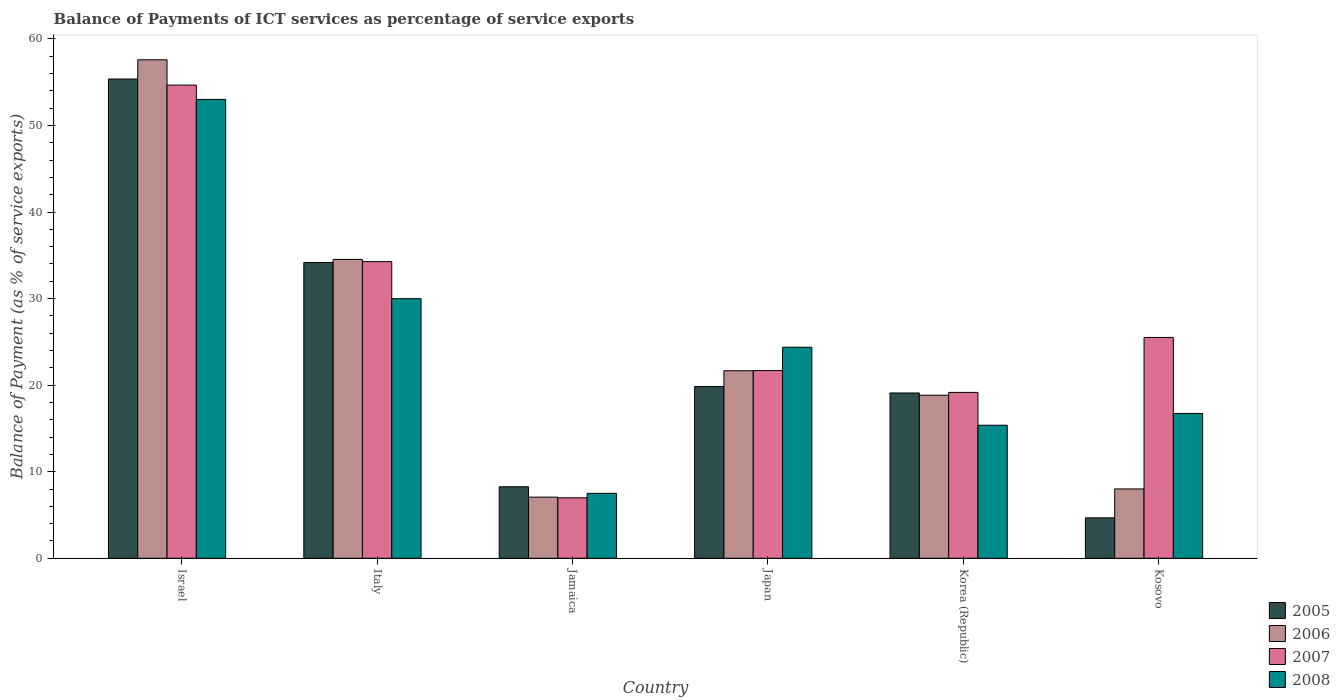How many different coloured bars are there?
Offer a terse response. 4. How many groups of bars are there?
Keep it short and to the point. 6. Are the number of bars on each tick of the X-axis equal?
Offer a very short reply. Yes. How many bars are there on the 2nd tick from the right?
Offer a very short reply. 4. What is the label of the 5th group of bars from the left?
Your answer should be very brief. Korea (Republic). What is the balance of payments of ICT services in 2005 in Italy?
Your answer should be very brief. 34.17. Across all countries, what is the maximum balance of payments of ICT services in 2006?
Ensure brevity in your answer.  57.59. Across all countries, what is the minimum balance of payments of ICT services in 2008?
Make the answer very short. 7.5. In which country was the balance of payments of ICT services in 2005 maximum?
Make the answer very short. Israel. In which country was the balance of payments of ICT services in 2007 minimum?
Give a very brief answer. Jamaica. What is the total balance of payments of ICT services in 2008 in the graph?
Your response must be concise. 147. What is the difference between the balance of payments of ICT services in 2005 in Japan and that in Korea (Republic)?
Your answer should be very brief. 0.75. What is the difference between the balance of payments of ICT services in 2007 in Italy and the balance of payments of ICT services in 2008 in Kosovo?
Ensure brevity in your answer.  17.54. What is the average balance of payments of ICT services in 2005 per country?
Your answer should be compact. 23.57. What is the difference between the balance of payments of ICT services of/in 2005 and balance of payments of ICT services of/in 2007 in Japan?
Your response must be concise. -1.84. In how many countries, is the balance of payments of ICT services in 2005 greater than 22 %?
Offer a very short reply. 2. What is the ratio of the balance of payments of ICT services in 2007 in Israel to that in Japan?
Offer a terse response. 2.52. What is the difference between the highest and the second highest balance of payments of ICT services in 2008?
Provide a short and direct response. -5.61. What is the difference between the highest and the lowest balance of payments of ICT services in 2005?
Provide a short and direct response. 50.7. In how many countries, is the balance of payments of ICT services in 2005 greater than the average balance of payments of ICT services in 2005 taken over all countries?
Your response must be concise. 2. Is it the case that in every country, the sum of the balance of payments of ICT services in 2007 and balance of payments of ICT services in 2008 is greater than the balance of payments of ICT services in 2005?
Offer a very short reply. Yes. Are all the bars in the graph horizontal?
Give a very brief answer. No. What is the difference between two consecutive major ticks on the Y-axis?
Your response must be concise. 10. Does the graph contain grids?
Provide a short and direct response. No. Where does the legend appear in the graph?
Provide a short and direct response. Bottom right. How are the legend labels stacked?
Make the answer very short. Vertical. What is the title of the graph?
Offer a terse response. Balance of Payments of ICT services as percentage of service exports. What is the label or title of the X-axis?
Offer a very short reply. Country. What is the label or title of the Y-axis?
Offer a very short reply. Balance of Payment (as % of service exports). What is the Balance of Payment (as % of service exports) of 2005 in Israel?
Ensure brevity in your answer.  55.37. What is the Balance of Payment (as % of service exports) of 2006 in Israel?
Ensure brevity in your answer.  57.59. What is the Balance of Payment (as % of service exports) in 2007 in Israel?
Provide a succinct answer. 54.67. What is the Balance of Payment (as % of service exports) in 2008 in Israel?
Provide a succinct answer. 53.02. What is the Balance of Payment (as % of service exports) of 2005 in Italy?
Make the answer very short. 34.17. What is the Balance of Payment (as % of service exports) of 2006 in Italy?
Your answer should be very brief. 34.53. What is the Balance of Payment (as % of service exports) in 2007 in Italy?
Make the answer very short. 34.28. What is the Balance of Payment (as % of service exports) of 2008 in Italy?
Your response must be concise. 29.99. What is the Balance of Payment (as % of service exports) in 2005 in Jamaica?
Offer a very short reply. 8.26. What is the Balance of Payment (as % of service exports) of 2006 in Jamaica?
Your answer should be very brief. 7.06. What is the Balance of Payment (as % of service exports) of 2007 in Jamaica?
Give a very brief answer. 6.99. What is the Balance of Payment (as % of service exports) in 2008 in Jamaica?
Give a very brief answer. 7.5. What is the Balance of Payment (as % of service exports) of 2005 in Japan?
Offer a very short reply. 19.85. What is the Balance of Payment (as % of service exports) in 2006 in Japan?
Offer a terse response. 21.67. What is the Balance of Payment (as % of service exports) of 2007 in Japan?
Give a very brief answer. 21.69. What is the Balance of Payment (as % of service exports) of 2008 in Japan?
Your response must be concise. 24.38. What is the Balance of Payment (as % of service exports) in 2005 in Korea (Republic)?
Offer a terse response. 19.1. What is the Balance of Payment (as % of service exports) in 2006 in Korea (Republic)?
Your answer should be compact. 18.84. What is the Balance of Payment (as % of service exports) in 2007 in Korea (Republic)?
Your answer should be compact. 19.16. What is the Balance of Payment (as % of service exports) in 2008 in Korea (Republic)?
Give a very brief answer. 15.37. What is the Balance of Payment (as % of service exports) of 2005 in Kosovo?
Offer a very short reply. 4.67. What is the Balance of Payment (as % of service exports) of 2006 in Kosovo?
Provide a succinct answer. 8.01. What is the Balance of Payment (as % of service exports) in 2007 in Kosovo?
Provide a short and direct response. 25.51. What is the Balance of Payment (as % of service exports) of 2008 in Kosovo?
Your answer should be compact. 16.73. Across all countries, what is the maximum Balance of Payment (as % of service exports) of 2005?
Your answer should be very brief. 55.37. Across all countries, what is the maximum Balance of Payment (as % of service exports) of 2006?
Offer a terse response. 57.59. Across all countries, what is the maximum Balance of Payment (as % of service exports) in 2007?
Give a very brief answer. 54.67. Across all countries, what is the maximum Balance of Payment (as % of service exports) of 2008?
Ensure brevity in your answer.  53.02. Across all countries, what is the minimum Balance of Payment (as % of service exports) of 2005?
Make the answer very short. 4.67. Across all countries, what is the minimum Balance of Payment (as % of service exports) of 2006?
Your answer should be very brief. 7.06. Across all countries, what is the minimum Balance of Payment (as % of service exports) in 2007?
Ensure brevity in your answer.  6.99. Across all countries, what is the minimum Balance of Payment (as % of service exports) in 2008?
Offer a very short reply. 7.5. What is the total Balance of Payment (as % of service exports) in 2005 in the graph?
Your response must be concise. 141.43. What is the total Balance of Payment (as % of service exports) in 2006 in the graph?
Your response must be concise. 147.7. What is the total Balance of Payment (as % of service exports) of 2007 in the graph?
Your response must be concise. 162.29. What is the total Balance of Payment (as % of service exports) in 2008 in the graph?
Keep it short and to the point. 147. What is the difference between the Balance of Payment (as % of service exports) in 2005 in Israel and that in Italy?
Ensure brevity in your answer.  21.2. What is the difference between the Balance of Payment (as % of service exports) of 2006 in Israel and that in Italy?
Provide a short and direct response. 23.06. What is the difference between the Balance of Payment (as % of service exports) of 2007 in Israel and that in Italy?
Offer a terse response. 20.39. What is the difference between the Balance of Payment (as % of service exports) in 2008 in Israel and that in Italy?
Ensure brevity in your answer.  23.02. What is the difference between the Balance of Payment (as % of service exports) in 2005 in Israel and that in Jamaica?
Provide a short and direct response. 47.11. What is the difference between the Balance of Payment (as % of service exports) in 2006 in Israel and that in Jamaica?
Make the answer very short. 50.53. What is the difference between the Balance of Payment (as % of service exports) in 2007 in Israel and that in Jamaica?
Offer a very short reply. 47.68. What is the difference between the Balance of Payment (as % of service exports) in 2008 in Israel and that in Jamaica?
Give a very brief answer. 45.51. What is the difference between the Balance of Payment (as % of service exports) in 2005 in Israel and that in Japan?
Give a very brief answer. 35.52. What is the difference between the Balance of Payment (as % of service exports) of 2006 in Israel and that in Japan?
Your response must be concise. 35.93. What is the difference between the Balance of Payment (as % of service exports) in 2007 in Israel and that in Japan?
Make the answer very short. 32.98. What is the difference between the Balance of Payment (as % of service exports) of 2008 in Israel and that in Japan?
Provide a short and direct response. 28.64. What is the difference between the Balance of Payment (as % of service exports) of 2005 in Israel and that in Korea (Republic)?
Ensure brevity in your answer.  36.28. What is the difference between the Balance of Payment (as % of service exports) of 2006 in Israel and that in Korea (Republic)?
Your response must be concise. 38.75. What is the difference between the Balance of Payment (as % of service exports) of 2007 in Israel and that in Korea (Republic)?
Your response must be concise. 35.5. What is the difference between the Balance of Payment (as % of service exports) in 2008 in Israel and that in Korea (Republic)?
Keep it short and to the point. 37.64. What is the difference between the Balance of Payment (as % of service exports) in 2005 in Israel and that in Kosovo?
Keep it short and to the point. 50.7. What is the difference between the Balance of Payment (as % of service exports) of 2006 in Israel and that in Kosovo?
Your answer should be very brief. 49.58. What is the difference between the Balance of Payment (as % of service exports) of 2007 in Israel and that in Kosovo?
Your answer should be very brief. 29.15. What is the difference between the Balance of Payment (as % of service exports) in 2008 in Israel and that in Kosovo?
Your answer should be very brief. 36.29. What is the difference between the Balance of Payment (as % of service exports) of 2005 in Italy and that in Jamaica?
Offer a terse response. 25.91. What is the difference between the Balance of Payment (as % of service exports) of 2006 in Italy and that in Jamaica?
Offer a terse response. 27.47. What is the difference between the Balance of Payment (as % of service exports) in 2007 in Italy and that in Jamaica?
Offer a very short reply. 27.29. What is the difference between the Balance of Payment (as % of service exports) of 2008 in Italy and that in Jamaica?
Provide a succinct answer. 22.49. What is the difference between the Balance of Payment (as % of service exports) in 2005 in Italy and that in Japan?
Give a very brief answer. 14.33. What is the difference between the Balance of Payment (as % of service exports) in 2006 in Italy and that in Japan?
Your answer should be very brief. 12.87. What is the difference between the Balance of Payment (as % of service exports) of 2007 in Italy and that in Japan?
Your answer should be very brief. 12.59. What is the difference between the Balance of Payment (as % of service exports) in 2008 in Italy and that in Japan?
Make the answer very short. 5.61. What is the difference between the Balance of Payment (as % of service exports) of 2005 in Italy and that in Korea (Republic)?
Your answer should be compact. 15.08. What is the difference between the Balance of Payment (as % of service exports) in 2006 in Italy and that in Korea (Republic)?
Give a very brief answer. 15.69. What is the difference between the Balance of Payment (as % of service exports) of 2007 in Italy and that in Korea (Republic)?
Give a very brief answer. 15.11. What is the difference between the Balance of Payment (as % of service exports) in 2008 in Italy and that in Korea (Republic)?
Provide a succinct answer. 14.62. What is the difference between the Balance of Payment (as % of service exports) of 2005 in Italy and that in Kosovo?
Make the answer very short. 29.5. What is the difference between the Balance of Payment (as % of service exports) in 2006 in Italy and that in Kosovo?
Keep it short and to the point. 26.52. What is the difference between the Balance of Payment (as % of service exports) in 2007 in Italy and that in Kosovo?
Your response must be concise. 8.76. What is the difference between the Balance of Payment (as % of service exports) in 2008 in Italy and that in Kosovo?
Provide a short and direct response. 13.26. What is the difference between the Balance of Payment (as % of service exports) of 2005 in Jamaica and that in Japan?
Offer a very short reply. -11.59. What is the difference between the Balance of Payment (as % of service exports) in 2006 in Jamaica and that in Japan?
Give a very brief answer. -14.6. What is the difference between the Balance of Payment (as % of service exports) of 2007 in Jamaica and that in Japan?
Keep it short and to the point. -14.7. What is the difference between the Balance of Payment (as % of service exports) in 2008 in Jamaica and that in Japan?
Offer a terse response. -16.88. What is the difference between the Balance of Payment (as % of service exports) in 2005 in Jamaica and that in Korea (Republic)?
Give a very brief answer. -10.83. What is the difference between the Balance of Payment (as % of service exports) of 2006 in Jamaica and that in Korea (Republic)?
Provide a succinct answer. -11.78. What is the difference between the Balance of Payment (as % of service exports) of 2007 in Jamaica and that in Korea (Republic)?
Provide a short and direct response. -12.18. What is the difference between the Balance of Payment (as % of service exports) of 2008 in Jamaica and that in Korea (Republic)?
Offer a terse response. -7.87. What is the difference between the Balance of Payment (as % of service exports) of 2005 in Jamaica and that in Kosovo?
Give a very brief answer. 3.59. What is the difference between the Balance of Payment (as % of service exports) in 2006 in Jamaica and that in Kosovo?
Give a very brief answer. -0.95. What is the difference between the Balance of Payment (as % of service exports) of 2007 in Jamaica and that in Kosovo?
Your answer should be compact. -18.53. What is the difference between the Balance of Payment (as % of service exports) in 2008 in Jamaica and that in Kosovo?
Make the answer very short. -9.23. What is the difference between the Balance of Payment (as % of service exports) of 2005 in Japan and that in Korea (Republic)?
Your answer should be very brief. 0.75. What is the difference between the Balance of Payment (as % of service exports) of 2006 in Japan and that in Korea (Republic)?
Your answer should be compact. 2.83. What is the difference between the Balance of Payment (as % of service exports) of 2007 in Japan and that in Korea (Republic)?
Your response must be concise. 2.52. What is the difference between the Balance of Payment (as % of service exports) in 2008 in Japan and that in Korea (Republic)?
Offer a very short reply. 9.01. What is the difference between the Balance of Payment (as % of service exports) of 2005 in Japan and that in Kosovo?
Your response must be concise. 15.18. What is the difference between the Balance of Payment (as % of service exports) in 2006 in Japan and that in Kosovo?
Your answer should be very brief. 13.66. What is the difference between the Balance of Payment (as % of service exports) of 2007 in Japan and that in Kosovo?
Your answer should be very brief. -3.83. What is the difference between the Balance of Payment (as % of service exports) in 2008 in Japan and that in Kosovo?
Give a very brief answer. 7.65. What is the difference between the Balance of Payment (as % of service exports) of 2005 in Korea (Republic) and that in Kosovo?
Give a very brief answer. 14.43. What is the difference between the Balance of Payment (as % of service exports) in 2006 in Korea (Republic) and that in Kosovo?
Your response must be concise. 10.83. What is the difference between the Balance of Payment (as % of service exports) of 2007 in Korea (Republic) and that in Kosovo?
Provide a succinct answer. -6.35. What is the difference between the Balance of Payment (as % of service exports) of 2008 in Korea (Republic) and that in Kosovo?
Provide a short and direct response. -1.36. What is the difference between the Balance of Payment (as % of service exports) in 2005 in Israel and the Balance of Payment (as % of service exports) in 2006 in Italy?
Offer a terse response. 20.84. What is the difference between the Balance of Payment (as % of service exports) of 2005 in Israel and the Balance of Payment (as % of service exports) of 2007 in Italy?
Ensure brevity in your answer.  21.1. What is the difference between the Balance of Payment (as % of service exports) in 2005 in Israel and the Balance of Payment (as % of service exports) in 2008 in Italy?
Offer a very short reply. 25.38. What is the difference between the Balance of Payment (as % of service exports) in 2006 in Israel and the Balance of Payment (as % of service exports) in 2007 in Italy?
Give a very brief answer. 23.32. What is the difference between the Balance of Payment (as % of service exports) in 2006 in Israel and the Balance of Payment (as % of service exports) in 2008 in Italy?
Ensure brevity in your answer.  27.6. What is the difference between the Balance of Payment (as % of service exports) in 2007 in Israel and the Balance of Payment (as % of service exports) in 2008 in Italy?
Make the answer very short. 24.67. What is the difference between the Balance of Payment (as % of service exports) in 2005 in Israel and the Balance of Payment (as % of service exports) in 2006 in Jamaica?
Make the answer very short. 48.31. What is the difference between the Balance of Payment (as % of service exports) of 2005 in Israel and the Balance of Payment (as % of service exports) of 2007 in Jamaica?
Offer a very short reply. 48.39. What is the difference between the Balance of Payment (as % of service exports) of 2005 in Israel and the Balance of Payment (as % of service exports) of 2008 in Jamaica?
Keep it short and to the point. 47.87. What is the difference between the Balance of Payment (as % of service exports) in 2006 in Israel and the Balance of Payment (as % of service exports) in 2007 in Jamaica?
Provide a succinct answer. 50.61. What is the difference between the Balance of Payment (as % of service exports) in 2006 in Israel and the Balance of Payment (as % of service exports) in 2008 in Jamaica?
Provide a succinct answer. 50.09. What is the difference between the Balance of Payment (as % of service exports) in 2007 in Israel and the Balance of Payment (as % of service exports) in 2008 in Jamaica?
Your answer should be very brief. 47.16. What is the difference between the Balance of Payment (as % of service exports) of 2005 in Israel and the Balance of Payment (as % of service exports) of 2006 in Japan?
Your answer should be compact. 33.71. What is the difference between the Balance of Payment (as % of service exports) of 2005 in Israel and the Balance of Payment (as % of service exports) of 2007 in Japan?
Make the answer very short. 33.69. What is the difference between the Balance of Payment (as % of service exports) in 2005 in Israel and the Balance of Payment (as % of service exports) in 2008 in Japan?
Your answer should be very brief. 30.99. What is the difference between the Balance of Payment (as % of service exports) of 2006 in Israel and the Balance of Payment (as % of service exports) of 2007 in Japan?
Offer a very short reply. 35.91. What is the difference between the Balance of Payment (as % of service exports) in 2006 in Israel and the Balance of Payment (as % of service exports) in 2008 in Japan?
Offer a terse response. 33.21. What is the difference between the Balance of Payment (as % of service exports) in 2007 in Israel and the Balance of Payment (as % of service exports) in 2008 in Japan?
Your answer should be very brief. 30.28. What is the difference between the Balance of Payment (as % of service exports) of 2005 in Israel and the Balance of Payment (as % of service exports) of 2006 in Korea (Republic)?
Your answer should be compact. 36.53. What is the difference between the Balance of Payment (as % of service exports) of 2005 in Israel and the Balance of Payment (as % of service exports) of 2007 in Korea (Republic)?
Provide a short and direct response. 36.21. What is the difference between the Balance of Payment (as % of service exports) of 2005 in Israel and the Balance of Payment (as % of service exports) of 2008 in Korea (Republic)?
Your answer should be very brief. 40. What is the difference between the Balance of Payment (as % of service exports) in 2006 in Israel and the Balance of Payment (as % of service exports) in 2007 in Korea (Republic)?
Your answer should be compact. 38.43. What is the difference between the Balance of Payment (as % of service exports) in 2006 in Israel and the Balance of Payment (as % of service exports) in 2008 in Korea (Republic)?
Provide a succinct answer. 42.22. What is the difference between the Balance of Payment (as % of service exports) in 2007 in Israel and the Balance of Payment (as % of service exports) in 2008 in Korea (Republic)?
Offer a very short reply. 39.29. What is the difference between the Balance of Payment (as % of service exports) of 2005 in Israel and the Balance of Payment (as % of service exports) of 2006 in Kosovo?
Provide a succinct answer. 47.36. What is the difference between the Balance of Payment (as % of service exports) in 2005 in Israel and the Balance of Payment (as % of service exports) in 2007 in Kosovo?
Provide a succinct answer. 29.86. What is the difference between the Balance of Payment (as % of service exports) in 2005 in Israel and the Balance of Payment (as % of service exports) in 2008 in Kosovo?
Your answer should be very brief. 38.64. What is the difference between the Balance of Payment (as % of service exports) in 2006 in Israel and the Balance of Payment (as % of service exports) in 2007 in Kosovo?
Your answer should be very brief. 32.08. What is the difference between the Balance of Payment (as % of service exports) of 2006 in Israel and the Balance of Payment (as % of service exports) of 2008 in Kosovo?
Your answer should be very brief. 40.86. What is the difference between the Balance of Payment (as % of service exports) of 2007 in Israel and the Balance of Payment (as % of service exports) of 2008 in Kosovo?
Ensure brevity in your answer.  37.94. What is the difference between the Balance of Payment (as % of service exports) of 2005 in Italy and the Balance of Payment (as % of service exports) of 2006 in Jamaica?
Your answer should be compact. 27.11. What is the difference between the Balance of Payment (as % of service exports) in 2005 in Italy and the Balance of Payment (as % of service exports) in 2007 in Jamaica?
Keep it short and to the point. 27.19. What is the difference between the Balance of Payment (as % of service exports) in 2005 in Italy and the Balance of Payment (as % of service exports) in 2008 in Jamaica?
Make the answer very short. 26.67. What is the difference between the Balance of Payment (as % of service exports) in 2006 in Italy and the Balance of Payment (as % of service exports) in 2007 in Jamaica?
Keep it short and to the point. 27.54. What is the difference between the Balance of Payment (as % of service exports) in 2006 in Italy and the Balance of Payment (as % of service exports) in 2008 in Jamaica?
Offer a terse response. 27.03. What is the difference between the Balance of Payment (as % of service exports) of 2007 in Italy and the Balance of Payment (as % of service exports) of 2008 in Jamaica?
Offer a terse response. 26.77. What is the difference between the Balance of Payment (as % of service exports) in 2005 in Italy and the Balance of Payment (as % of service exports) in 2006 in Japan?
Offer a very short reply. 12.51. What is the difference between the Balance of Payment (as % of service exports) of 2005 in Italy and the Balance of Payment (as % of service exports) of 2007 in Japan?
Ensure brevity in your answer.  12.49. What is the difference between the Balance of Payment (as % of service exports) in 2005 in Italy and the Balance of Payment (as % of service exports) in 2008 in Japan?
Ensure brevity in your answer.  9.79. What is the difference between the Balance of Payment (as % of service exports) of 2006 in Italy and the Balance of Payment (as % of service exports) of 2007 in Japan?
Offer a very short reply. 12.85. What is the difference between the Balance of Payment (as % of service exports) in 2006 in Italy and the Balance of Payment (as % of service exports) in 2008 in Japan?
Ensure brevity in your answer.  10.15. What is the difference between the Balance of Payment (as % of service exports) of 2007 in Italy and the Balance of Payment (as % of service exports) of 2008 in Japan?
Keep it short and to the point. 9.89. What is the difference between the Balance of Payment (as % of service exports) in 2005 in Italy and the Balance of Payment (as % of service exports) in 2006 in Korea (Republic)?
Provide a short and direct response. 15.34. What is the difference between the Balance of Payment (as % of service exports) of 2005 in Italy and the Balance of Payment (as % of service exports) of 2007 in Korea (Republic)?
Offer a very short reply. 15.01. What is the difference between the Balance of Payment (as % of service exports) of 2005 in Italy and the Balance of Payment (as % of service exports) of 2008 in Korea (Republic)?
Ensure brevity in your answer.  18.8. What is the difference between the Balance of Payment (as % of service exports) in 2006 in Italy and the Balance of Payment (as % of service exports) in 2007 in Korea (Republic)?
Give a very brief answer. 15.37. What is the difference between the Balance of Payment (as % of service exports) of 2006 in Italy and the Balance of Payment (as % of service exports) of 2008 in Korea (Republic)?
Ensure brevity in your answer.  19.16. What is the difference between the Balance of Payment (as % of service exports) of 2007 in Italy and the Balance of Payment (as % of service exports) of 2008 in Korea (Republic)?
Make the answer very short. 18.9. What is the difference between the Balance of Payment (as % of service exports) in 2005 in Italy and the Balance of Payment (as % of service exports) in 2006 in Kosovo?
Your answer should be very brief. 26.16. What is the difference between the Balance of Payment (as % of service exports) of 2005 in Italy and the Balance of Payment (as % of service exports) of 2007 in Kosovo?
Keep it short and to the point. 8.66. What is the difference between the Balance of Payment (as % of service exports) of 2005 in Italy and the Balance of Payment (as % of service exports) of 2008 in Kosovo?
Offer a very short reply. 17.44. What is the difference between the Balance of Payment (as % of service exports) in 2006 in Italy and the Balance of Payment (as % of service exports) in 2007 in Kosovo?
Provide a succinct answer. 9.02. What is the difference between the Balance of Payment (as % of service exports) in 2006 in Italy and the Balance of Payment (as % of service exports) in 2008 in Kosovo?
Your response must be concise. 17.8. What is the difference between the Balance of Payment (as % of service exports) of 2007 in Italy and the Balance of Payment (as % of service exports) of 2008 in Kosovo?
Ensure brevity in your answer.  17.54. What is the difference between the Balance of Payment (as % of service exports) in 2005 in Jamaica and the Balance of Payment (as % of service exports) in 2006 in Japan?
Offer a terse response. -13.4. What is the difference between the Balance of Payment (as % of service exports) of 2005 in Jamaica and the Balance of Payment (as % of service exports) of 2007 in Japan?
Offer a terse response. -13.42. What is the difference between the Balance of Payment (as % of service exports) in 2005 in Jamaica and the Balance of Payment (as % of service exports) in 2008 in Japan?
Your answer should be very brief. -16.12. What is the difference between the Balance of Payment (as % of service exports) of 2006 in Jamaica and the Balance of Payment (as % of service exports) of 2007 in Japan?
Provide a succinct answer. -14.62. What is the difference between the Balance of Payment (as % of service exports) in 2006 in Jamaica and the Balance of Payment (as % of service exports) in 2008 in Japan?
Ensure brevity in your answer.  -17.32. What is the difference between the Balance of Payment (as % of service exports) of 2007 in Jamaica and the Balance of Payment (as % of service exports) of 2008 in Japan?
Provide a succinct answer. -17.39. What is the difference between the Balance of Payment (as % of service exports) in 2005 in Jamaica and the Balance of Payment (as % of service exports) in 2006 in Korea (Republic)?
Provide a succinct answer. -10.58. What is the difference between the Balance of Payment (as % of service exports) in 2005 in Jamaica and the Balance of Payment (as % of service exports) in 2007 in Korea (Republic)?
Ensure brevity in your answer.  -10.9. What is the difference between the Balance of Payment (as % of service exports) in 2005 in Jamaica and the Balance of Payment (as % of service exports) in 2008 in Korea (Republic)?
Ensure brevity in your answer.  -7.11. What is the difference between the Balance of Payment (as % of service exports) in 2006 in Jamaica and the Balance of Payment (as % of service exports) in 2007 in Korea (Republic)?
Your response must be concise. -12.1. What is the difference between the Balance of Payment (as % of service exports) in 2006 in Jamaica and the Balance of Payment (as % of service exports) in 2008 in Korea (Republic)?
Your answer should be compact. -8.31. What is the difference between the Balance of Payment (as % of service exports) of 2007 in Jamaica and the Balance of Payment (as % of service exports) of 2008 in Korea (Republic)?
Ensure brevity in your answer.  -8.39. What is the difference between the Balance of Payment (as % of service exports) in 2005 in Jamaica and the Balance of Payment (as % of service exports) in 2006 in Kosovo?
Give a very brief answer. 0.25. What is the difference between the Balance of Payment (as % of service exports) in 2005 in Jamaica and the Balance of Payment (as % of service exports) in 2007 in Kosovo?
Keep it short and to the point. -17.25. What is the difference between the Balance of Payment (as % of service exports) in 2005 in Jamaica and the Balance of Payment (as % of service exports) in 2008 in Kosovo?
Your answer should be compact. -8.47. What is the difference between the Balance of Payment (as % of service exports) of 2006 in Jamaica and the Balance of Payment (as % of service exports) of 2007 in Kosovo?
Ensure brevity in your answer.  -18.45. What is the difference between the Balance of Payment (as % of service exports) in 2006 in Jamaica and the Balance of Payment (as % of service exports) in 2008 in Kosovo?
Ensure brevity in your answer.  -9.67. What is the difference between the Balance of Payment (as % of service exports) in 2007 in Jamaica and the Balance of Payment (as % of service exports) in 2008 in Kosovo?
Make the answer very short. -9.74. What is the difference between the Balance of Payment (as % of service exports) of 2005 in Japan and the Balance of Payment (as % of service exports) of 2006 in Korea (Republic)?
Offer a terse response. 1.01. What is the difference between the Balance of Payment (as % of service exports) of 2005 in Japan and the Balance of Payment (as % of service exports) of 2007 in Korea (Republic)?
Make the answer very short. 0.68. What is the difference between the Balance of Payment (as % of service exports) in 2005 in Japan and the Balance of Payment (as % of service exports) in 2008 in Korea (Republic)?
Offer a very short reply. 4.48. What is the difference between the Balance of Payment (as % of service exports) of 2006 in Japan and the Balance of Payment (as % of service exports) of 2007 in Korea (Republic)?
Give a very brief answer. 2.5. What is the difference between the Balance of Payment (as % of service exports) in 2006 in Japan and the Balance of Payment (as % of service exports) in 2008 in Korea (Republic)?
Provide a succinct answer. 6.29. What is the difference between the Balance of Payment (as % of service exports) of 2007 in Japan and the Balance of Payment (as % of service exports) of 2008 in Korea (Republic)?
Ensure brevity in your answer.  6.31. What is the difference between the Balance of Payment (as % of service exports) in 2005 in Japan and the Balance of Payment (as % of service exports) in 2006 in Kosovo?
Provide a succinct answer. 11.84. What is the difference between the Balance of Payment (as % of service exports) in 2005 in Japan and the Balance of Payment (as % of service exports) in 2007 in Kosovo?
Make the answer very short. -5.67. What is the difference between the Balance of Payment (as % of service exports) of 2005 in Japan and the Balance of Payment (as % of service exports) of 2008 in Kosovo?
Keep it short and to the point. 3.12. What is the difference between the Balance of Payment (as % of service exports) of 2006 in Japan and the Balance of Payment (as % of service exports) of 2007 in Kosovo?
Ensure brevity in your answer.  -3.85. What is the difference between the Balance of Payment (as % of service exports) in 2006 in Japan and the Balance of Payment (as % of service exports) in 2008 in Kosovo?
Ensure brevity in your answer.  4.93. What is the difference between the Balance of Payment (as % of service exports) of 2007 in Japan and the Balance of Payment (as % of service exports) of 2008 in Kosovo?
Ensure brevity in your answer.  4.95. What is the difference between the Balance of Payment (as % of service exports) of 2005 in Korea (Republic) and the Balance of Payment (as % of service exports) of 2006 in Kosovo?
Offer a very short reply. 11.09. What is the difference between the Balance of Payment (as % of service exports) in 2005 in Korea (Republic) and the Balance of Payment (as % of service exports) in 2007 in Kosovo?
Give a very brief answer. -6.42. What is the difference between the Balance of Payment (as % of service exports) in 2005 in Korea (Republic) and the Balance of Payment (as % of service exports) in 2008 in Kosovo?
Provide a succinct answer. 2.37. What is the difference between the Balance of Payment (as % of service exports) in 2006 in Korea (Republic) and the Balance of Payment (as % of service exports) in 2007 in Kosovo?
Keep it short and to the point. -6.68. What is the difference between the Balance of Payment (as % of service exports) of 2006 in Korea (Republic) and the Balance of Payment (as % of service exports) of 2008 in Kosovo?
Your answer should be very brief. 2.11. What is the difference between the Balance of Payment (as % of service exports) of 2007 in Korea (Republic) and the Balance of Payment (as % of service exports) of 2008 in Kosovo?
Give a very brief answer. 2.43. What is the average Balance of Payment (as % of service exports) in 2005 per country?
Provide a succinct answer. 23.57. What is the average Balance of Payment (as % of service exports) in 2006 per country?
Your answer should be compact. 24.62. What is the average Balance of Payment (as % of service exports) in 2007 per country?
Make the answer very short. 27.05. What is the average Balance of Payment (as % of service exports) of 2008 per country?
Your answer should be compact. 24.5. What is the difference between the Balance of Payment (as % of service exports) of 2005 and Balance of Payment (as % of service exports) of 2006 in Israel?
Your answer should be compact. -2.22. What is the difference between the Balance of Payment (as % of service exports) of 2005 and Balance of Payment (as % of service exports) of 2007 in Israel?
Make the answer very short. 0.71. What is the difference between the Balance of Payment (as % of service exports) in 2005 and Balance of Payment (as % of service exports) in 2008 in Israel?
Keep it short and to the point. 2.36. What is the difference between the Balance of Payment (as % of service exports) in 2006 and Balance of Payment (as % of service exports) in 2007 in Israel?
Offer a terse response. 2.93. What is the difference between the Balance of Payment (as % of service exports) in 2006 and Balance of Payment (as % of service exports) in 2008 in Israel?
Your answer should be very brief. 4.57. What is the difference between the Balance of Payment (as % of service exports) of 2007 and Balance of Payment (as % of service exports) of 2008 in Israel?
Offer a terse response. 1.65. What is the difference between the Balance of Payment (as % of service exports) in 2005 and Balance of Payment (as % of service exports) in 2006 in Italy?
Your answer should be very brief. -0.36. What is the difference between the Balance of Payment (as % of service exports) of 2005 and Balance of Payment (as % of service exports) of 2007 in Italy?
Your response must be concise. -0.1. What is the difference between the Balance of Payment (as % of service exports) of 2005 and Balance of Payment (as % of service exports) of 2008 in Italy?
Ensure brevity in your answer.  4.18. What is the difference between the Balance of Payment (as % of service exports) of 2006 and Balance of Payment (as % of service exports) of 2007 in Italy?
Keep it short and to the point. 0.26. What is the difference between the Balance of Payment (as % of service exports) of 2006 and Balance of Payment (as % of service exports) of 2008 in Italy?
Your response must be concise. 4.54. What is the difference between the Balance of Payment (as % of service exports) of 2007 and Balance of Payment (as % of service exports) of 2008 in Italy?
Give a very brief answer. 4.28. What is the difference between the Balance of Payment (as % of service exports) of 2005 and Balance of Payment (as % of service exports) of 2006 in Jamaica?
Keep it short and to the point. 1.2. What is the difference between the Balance of Payment (as % of service exports) of 2005 and Balance of Payment (as % of service exports) of 2007 in Jamaica?
Keep it short and to the point. 1.28. What is the difference between the Balance of Payment (as % of service exports) of 2005 and Balance of Payment (as % of service exports) of 2008 in Jamaica?
Offer a very short reply. 0.76. What is the difference between the Balance of Payment (as % of service exports) in 2006 and Balance of Payment (as % of service exports) in 2007 in Jamaica?
Make the answer very short. 0.08. What is the difference between the Balance of Payment (as % of service exports) of 2006 and Balance of Payment (as % of service exports) of 2008 in Jamaica?
Provide a succinct answer. -0.44. What is the difference between the Balance of Payment (as % of service exports) of 2007 and Balance of Payment (as % of service exports) of 2008 in Jamaica?
Give a very brief answer. -0.52. What is the difference between the Balance of Payment (as % of service exports) in 2005 and Balance of Payment (as % of service exports) in 2006 in Japan?
Keep it short and to the point. -1.82. What is the difference between the Balance of Payment (as % of service exports) of 2005 and Balance of Payment (as % of service exports) of 2007 in Japan?
Offer a very short reply. -1.84. What is the difference between the Balance of Payment (as % of service exports) in 2005 and Balance of Payment (as % of service exports) in 2008 in Japan?
Your answer should be very brief. -4.53. What is the difference between the Balance of Payment (as % of service exports) of 2006 and Balance of Payment (as % of service exports) of 2007 in Japan?
Your answer should be very brief. -0.02. What is the difference between the Balance of Payment (as % of service exports) in 2006 and Balance of Payment (as % of service exports) in 2008 in Japan?
Provide a short and direct response. -2.72. What is the difference between the Balance of Payment (as % of service exports) in 2007 and Balance of Payment (as % of service exports) in 2008 in Japan?
Provide a short and direct response. -2.7. What is the difference between the Balance of Payment (as % of service exports) of 2005 and Balance of Payment (as % of service exports) of 2006 in Korea (Republic)?
Provide a short and direct response. 0.26. What is the difference between the Balance of Payment (as % of service exports) in 2005 and Balance of Payment (as % of service exports) in 2007 in Korea (Republic)?
Offer a terse response. -0.07. What is the difference between the Balance of Payment (as % of service exports) of 2005 and Balance of Payment (as % of service exports) of 2008 in Korea (Republic)?
Offer a terse response. 3.72. What is the difference between the Balance of Payment (as % of service exports) in 2006 and Balance of Payment (as % of service exports) in 2007 in Korea (Republic)?
Provide a succinct answer. -0.33. What is the difference between the Balance of Payment (as % of service exports) of 2006 and Balance of Payment (as % of service exports) of 2008 in Korea (Republic)?
Your answer should be compact. 3.46. What is the difference between the Balance of Payment (as % of service exports) of 2007 and Balance of Payment (as % of service exports) of 2008 in Korea (Republic)?
Offer a terse response. 3.79. What is the difference between the Balance of Payment (as % of service exports) of 2005 and Balance of Payment (as % of service exports) of 2006 in Kosovo?
Offer a terse response. -3.34. What is the difference between the Balance of Payment (as % of service exports) of 2005 and Balance of Payment (as % of service exports) of 2007 in Kosovo?
Offer a terse response. -20.84. What is the difference between the Balance of Payment (as % of service exports) of 2005 and Balance of Payment (as % of service exports) of 2008 in Kosovo?
Offer a very short reply. -12.06. What is the difference between the Balance of Payment (as % of service exports) of 2006 and Balance of Payment (as % of service exports) of 2007 in Kosovo?
Your answer should be very brief. -17.5. What is the difference between the Balance of Payment (as % of service exports) in 2006 and Balance of Payment (as % of service exports) in 2008 in Kosovo?
Your answer should be very brief. -8.72. What is the difference between the Balance of Payment (as % of service exports) of 2007 and Balance of Payment (as % of service exports) of 2008 in Kosovo?
Your answer should be very brief. 8.78. What is the ratio of the Balance of Payment (as % of service exports) in 2005 in Israel to that in Italy?
Ensure brevity in your answer.  1.62. What is the ratio of the Balance of Payment (as % of service exports) in 2006 in Israel to that in Italy?
Make the answer very short. 1.67. What is the ratio of the Balance of Payment (as % of service exports) of 2007 in Israel to that in Italy?
Keep it short and to the point. 1.59. What is the ratio of the Balance of Payment (as % of service exports) in 2008 in Israel to that in Italy?
Your answer should be very brief. 1.77. What is the ratio of the Balance of Payment (as % of service exports) in 2005 in Israel to that in Jamaica?
Provide a succinct answer. 6.7. What is the ratio of the Balance of Payment (as % of service exports) of 2006 in Israel to that in Jamaica?
Offer a very short reply. 8.15. What is the ratio of the Balance of Payment (as % of service exports) of 2007 in Israel to that in Jamaica?
Give a very brief answer. 7.82. What is the ratio of the Balance of Payment (as % of service exports) in 2008 in Israel to that in Jamaica?
Offer a terse response. 7.07. What is the ratio of the Balance of Payment (as % of service exports) in 2005 in Israel to that in Japan?
Give a very brief answer. 2.79. What is the ratio of the Balance of Payment (as % of service exports) of 2006 in Israel to that in Japan?
Ensure brevity in your answer.  2.66. What is the ratio of the Balance of Payment (as % of service exports) of 2007 in Israel to that in Japan?
Ensure brevity in your answer.  2.52. What is the ratio of the Balance of Payment (as % of service exports) of 2008 in Israel to that in Japan?
Offer a terse response. 2.17. What is the ratio of the Balance of Payment (as % of service exports) in 2005 in Israel to that in Korea (Republic)?
Offer a terse response. 2.9. What is the ratio of the Balance of Payment (as % of service exports) in 2006 in Israel to that in Korea (Republic)?
Your answer should be compact. 3.06. What is the ratio of the Balance of Payment (as % of service exports) in 2007 in Israel to that in Korea (Republic)?
Keep it short and to the point. 2.85. What is the ratio of the Balance of Payment (as % of service exports) in 2008 in Israel to that in Korea (Republic)?
Your answer should be very brief. 3.45. What is the ratio of the Balance of Payment (as % of service exports) of 2005 in Israel to that in Kosovo?
Your answer should be very brief. 11.85. What is the ratio of the Balance of Payment (as % of service exports) in 2006 in Israel to that in Kosovo?
Offer a terse response. 7.19. What is the ratio of the Balance of Payment (as % of service exports) of 2007 in Israel to that in Kosovo?
Give a very brief answer. 2.14. What is the ratio of the Balance of Payment (as % of service exports) of 2008 in Israel to that in Kosovo?
Provide a short and direct response. 3.17. What is the ratio of the Balance of Payment (as % of service exports) of 2005 in Italy to that in Jamaica?
Your answer should be compact. 4.14. What is the ratio of the Balance of Payment (as % of service exports) in 2006 in Italy to that in Jamaica?
Provide a short and direct response. 4.89. What is the ratio of the Balance of Payment (as % of service exports) of 2007 in Italy to that in Jamaica?
Offer a terse response. 4.91. What is the ratio of the Balance of Payment (as % of service exports) of 2008 in Italy to that in Jamaica?
Provide a short and direct response. 4. What is the ratio of the Balance of Payment (as % of service exports) of 2005 in Italy to that in Japan?
Offer a terse response. 1.72. What is the ratio of the Balance of Payment (as % of service exports) in 2006 in Italy to that in Japan?
Give a very brief answer. 1.59. What is the ratio of the Balance of Payment (as % of service exports) in 2007 in Italy to that in Japan?
Provide a succinct answer. 1.58. What is the ratio of the Balance of Payment (as % of service exports) in 2008 in Italy to that in Japan?
Offer a very short reply. 1.23. What is the ratio of the Balance of Payment (as % of service exports) in 2005 in Italy to that in Korea (Republic)?
Ensure brevity in your answer.  1.79. What is the ratio of the Balance of Payment (as % of service exports) of 2006 in Italy to that in Korea (Republic)?
Your response must be concise. 1.83. What is the ratio of the Balance of Payment (as % of service exports) in 2007 in Italy to that in Korea (Republic)?
Provide a succinct answer. 1.79. What is the ratio of the Balance of Payment (as % of service exports) of 2008 in Italy to that in Korea (Republic)?
Provide a short and direct response. 1.95. What is the ratio of the Balance of Payment (as % of service exports) in 2005 in Italy to that in Kosovo?
Offer a very short reply. 7.32. What is the ratio of the Balance of Payment (as % of service exports) of 2006 in Italy to that in Kosovo?
Your response must be concise. 4.31. What is the ratio of the Balance of Payment (as % of service exports) of 2007 in Italy to that in Kosovo?
Your response must be concise. 1.34. What is the ratio of the Balance of Payment (as % of service exports) in 2008 in Italy to that in Kosovo?
Offer a terse response. 1.79. What is the ratio of the Balance of Payment (as % of service exports) in 2005 in Jamaica to that in Japan?
Make the answer very short. 0.42. What is the ratio of the Balance of Payment (as % of service exports) of 2006 in Jamaica to that in Japan?
Your answer should be very brief. 0.33. What is the ratio of the Balance of Payment (as % of service exports) of 2007 in Jamaica to that in Japan?
Ensure brevity in your answer.  0.32. What is the ratio of the Balance of Payment (as % of service exports) in 2008 in Jamaica to that in Japan?
Provide a short and direct response. 0.31. What is the ratio of the Balance of Payment (as % of service exports) in 2005 in Jamaica to that in Korea (Republic)?
Ensure brevity in your answer.  0.43. What is the ratio of the Balance of Payment (as % of service exports) in 2006 in Jamaica to that in Korea (Republic)?
Make the answer very short. 0.37. What is the ratio of the Balance of Payment (as % of service exports) in 2007 in Jamaica to that in Korea (Republic)?
Provide a succinct answer. 0.36. What is the ratio of the Balance of Payment (as % of service exports) of 2008 in Jamaica to that in Korea (Republic)?
Offer a terse response. 0.49. What is the ratio of the Balance of Payment (as % of service exports) of 2005 in Jamaica to that in Kosovo?
Your response must be concise. 1.77. What is the ratio of the Balance of Payment (as % of service exports) of 2006 in Jamaica to that in Kosovo?
Keep it short and to the point. 0.88. What is the ratio of the Balance of Payment (as % of service exports) in 2007 in Jamaica to that in Kosovo?
Provide a succinct answer. 0.27. What is the ratio of the Balance of Payment (as % of service exports) in 2008 in Jamaica to that in Kosovo?
Offer a terse response. 0.45. What is the ratio of the Balance of Payment (as % of service exports) of 2005 in Japan to that in Korea (Republic)?
Your answer should be compact. 1.04. What is the ratio of the Balance of Payment (as % of service exports) in 2006 in Japan to that in Korea (Republic)?
Provide a short and direct response. 1.15. What is the ratio of the Balance of Payment (as % of service exports) in 2007 in Japan to that in Korea (Republic)?
Offer a terse response. 1.13. What is the ratio of the Balance of Payment (as % of service exports) in 2008 in Japan to that in Korea (Republic)?
Provide a succinct answer. 1.59. What is the ratio of the Balance of Payment (as % of service exports) of 2005 in Japan to that in Kosovo?
Offer a terse response. 4.25. What is the ratio of the Balance of Payment (as % of service exports) of 2006 in Japan to that in Kosovo?
Provide a succinct answer. 2.7. What is the ratio of the Balance of Payment (as % of service exports) in 2007 in Japan to that in Kosovo?
Your answer should be very brief. 0.85. What is the ratio of the Balance of Payment (as % of service exports) of 2008 in Japan to that in Kosovo?
Your response must be concise. 1.46. What is the ratio of the Balance of Payment (as % of service exports) of 2005 in Korea (Republic) to that in Kosovo?
Give a very brief answer. 4.09. What is the ratio of the Balance of Payment (as % of service exports) of 2006 in Korea (Republic) to that in Kosovo?
Offer a terse response. 2.35. What is the ratio of the Balance of Payment (as % of service exports) of 2007 in Korea (Republic) to that in Kosovo?
Keep it short and to the point. 0.75. What is the ratio of the Balance of Payment (as % of service exports) of 2008 in Korea (Republic) to that in Kosovo?
Your answer should be very brief. 0.92. What is the difference between the highest and the second highest Balance of Payment (as % of service exports) in 2005?
Your answer should be compact. 21.2. What is the difference between the highest and the second highest Balance of Payment (as % of service exports) in 2006?
Your response must be concise. 23.06. What is the difference between the highest and the second highest Balance of Payment (as % of service exports) of 2007?
Keep it short and to the point. 20.39. What is the difference between the highest and the second highest Balance of Payment (as % of service exports) of 2008?
Your answer should be very brief. 23.02. What is the difference between the highest and the lowest Balance of Payment (as % of service exports) of 2005?
Keep it short and to the point. 50.7. What is the difference between the highest and the lowest Balance of Payment (as % of service exports) of 2006?
Give a very brief answer. 50.53. What is the difference between the highest and the lowest Balance of Payment (as % of service exports) in 2007?
Your answer should be compact. 47.68. What is the difference between the highest and the lowest Balance of Payment (as % of service exports) of 2008?
Your response must be concise. 45.51. 